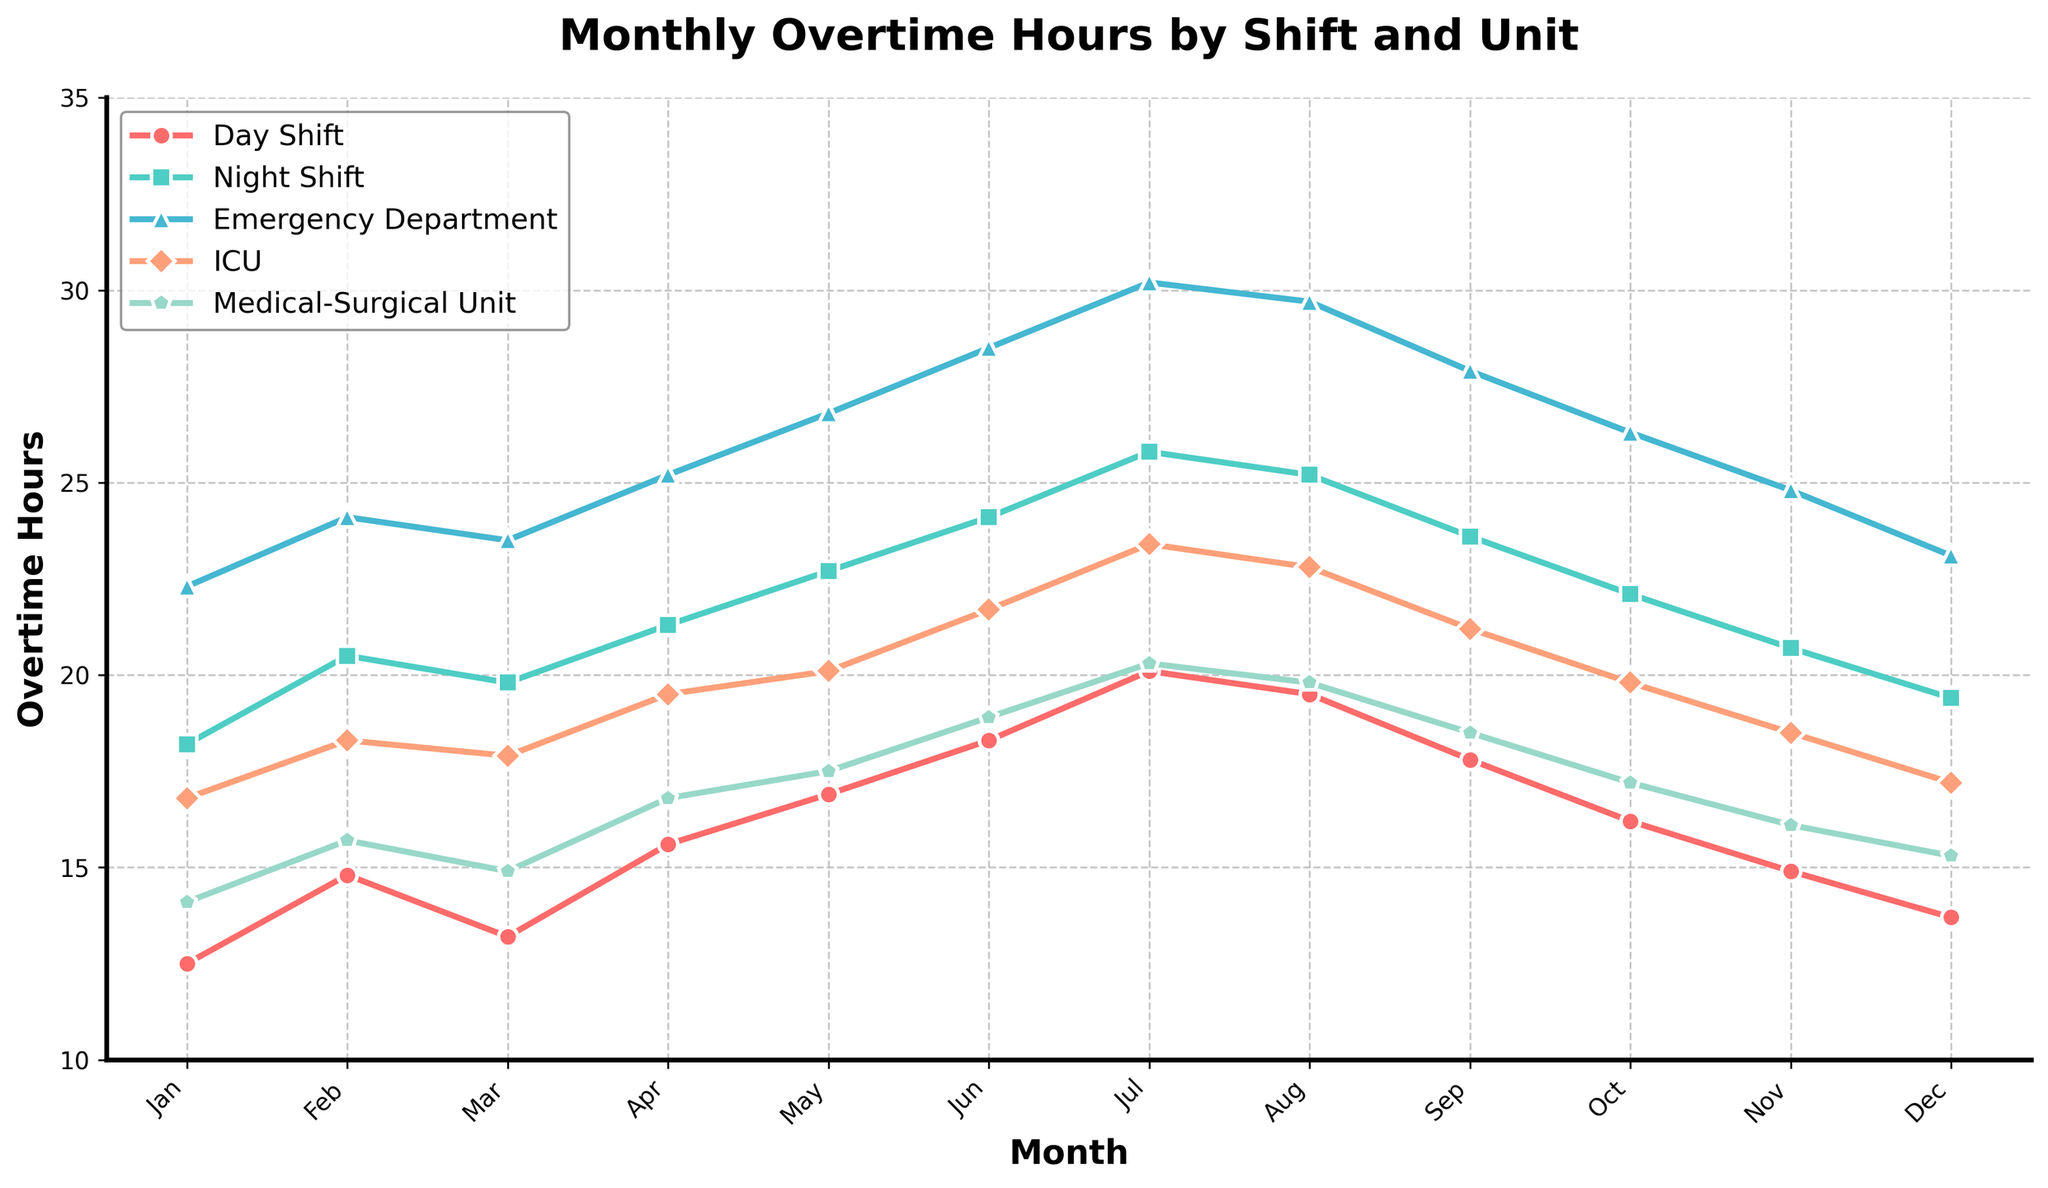What is the highest value of monthly overtime hours worked by the Night Shift? According to the plot, the highest monthly overtime hours worked by the Night Shift occur in July. The value can be found at the peak of the curve for the Night Shift.
Answer: 25.8 Which unit had the lowest overtime hours in March, and what was the value? To answer this, locate March on the x-axis and see which unit's line is the lowest. The Medical-Surgical Unit has the lowest point in March.
Answer: Medical-Surgical Unit, 14.9 What is the average overtime hours worked by the ICU nurses from January to December? Locate the ICU data points for each month and sum them up: (16.8 + 18.3 + 17.9 + 19.5 + 20.1 + 21.7 + 23.4 + 22.8 + 21.2 + 19.8 + 18.5 + 17.2) = 237.2. Then, divide by the number of months, 12. 237.2 / 12 = 19.77.
Answer: 19.77 By how much did the overtime hours for the Day Shift increase from January to June? Locate the overtime hours for the Day Shift in January and June: January is 12.5, and June is 18.3. Subtract the January value from the June value: 18.3 - 12.5 = 5.8
Answer: 5.8 Which shift or unit displayed the most consistent overtime hours month-to-month and what indicates this? To determine consistency, look for the line with the least variation in height over the months. The ICU line appears to have smaller fluctuations compared to others.
Answer: ICU Which shift experienced the highest increase in overtime hours between two successive months and what was that increase? Identify the steepest slope between months for all shifts. The steepest increase is from June to July for the Day Shift, increasing from 18.3 to 20.1. The increase is 20.1 - 18.3 = 1.8
Answer: Day Shift, 1.8 How many times did the overtime hours for the Emergency Department surpass 25 hours? Track the Emergency Department line and identify each monthly point where it crosses above 25. This happens in April, May, June, July, and August.
Answer: 5 Compare the overtime hours of the Medical-Surgical Unit in January to its value in December. Is there an increase or decrease, and by how much? Look at the Medical-Surgical Unit's values in January and December: January is 14.1, and December is 15.3. Subtract January’s value from December’s value: 15.3 - 14.1 = 1.2.
Answer: Increase, 1.2 By what percentage did the overtime hours for the Night Shift improve from July to August? Identify the Night Shift values for July and August: July is 25.8, and August is 25.2. Calculate the difference and then the percentage decrease: (25.8 - 25.2) / 25.8 x 100 = 2.33%.
Answer: 2.33% When was the overtime for the Emergency Department at its peak, and what was the value? Locate the highest point on the Emergency Department line. The highest overtime value is in July.
Answer: July, 30.2 